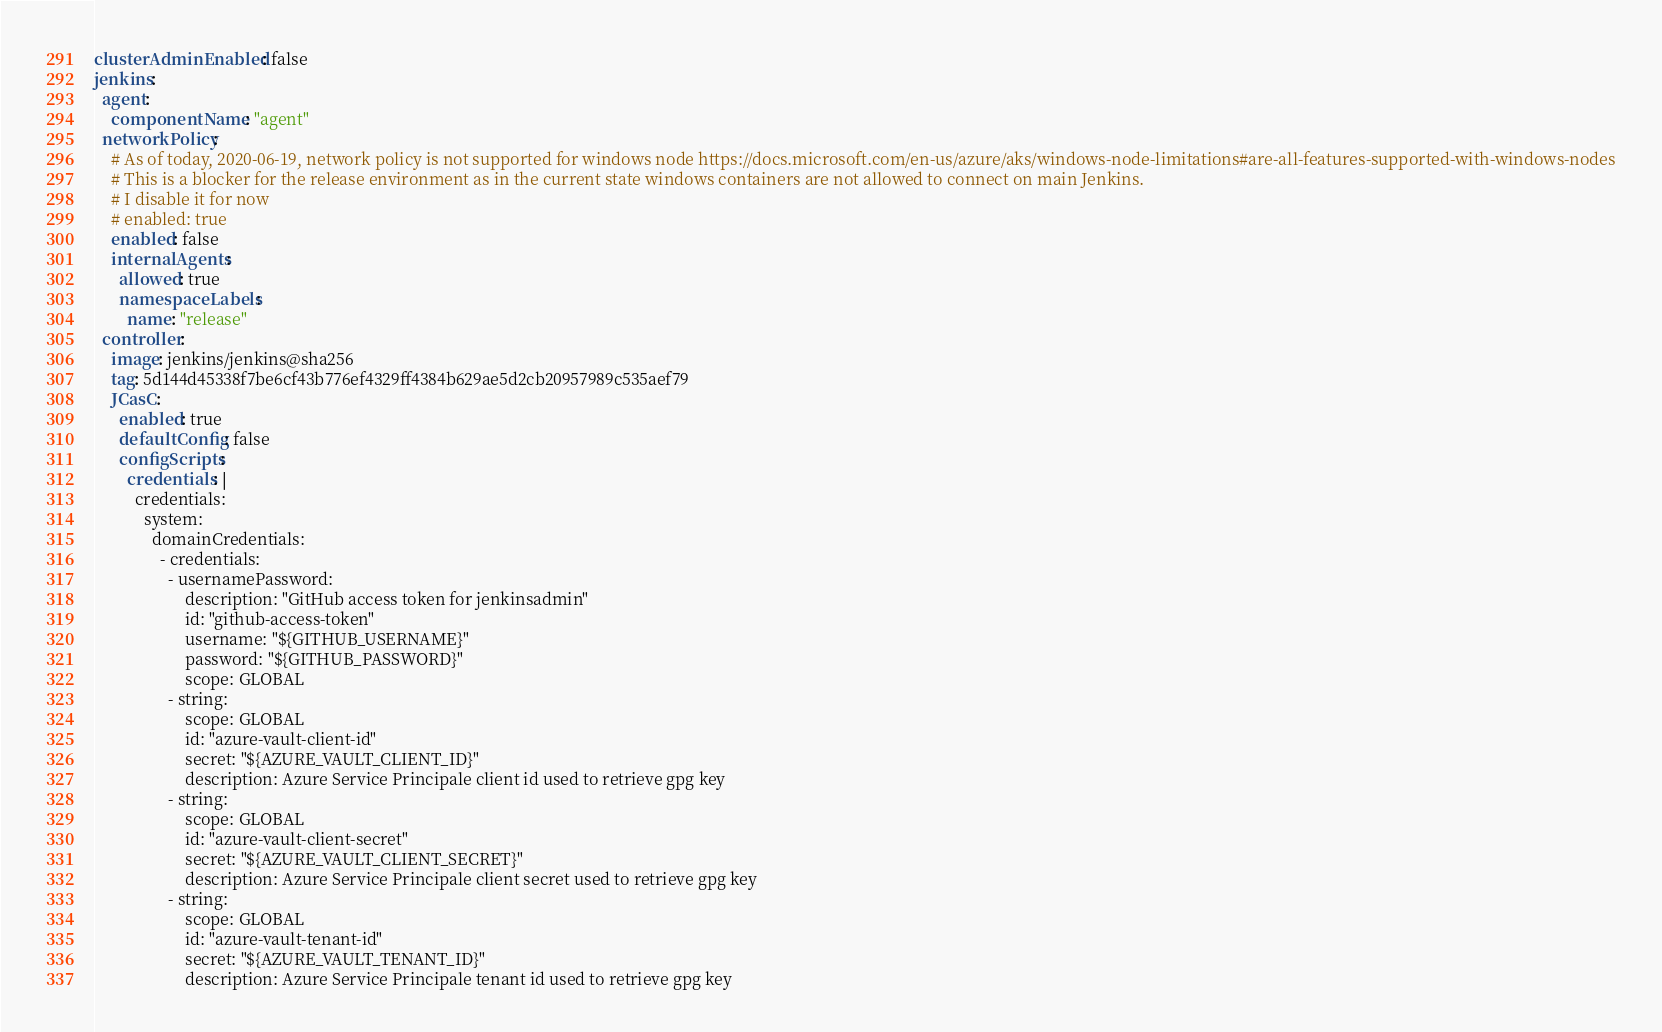<code> <loc_0><loc_0><loc_500><loc_500><_YAML_>clusterAdminEnabled: false
jenkins:
  agent:
    componentName: "agent"
  networkPolicy:
    # As of today, 2020-06-19, network policy is not supported for windows node https://docs.microsoft.com/en-us/azure/aks/windows-node-limitations#are-all-features-supported-with-windows-nodes
    # This is a blocker for the release environment as in the current state windows containers are not allowed to connect on main Jenkins.
    # I disable it for now
    # enabled: true
    enabled: false
    internalAgents:
      allowed: true
      namespaceLabels:
        name: "release"
  controller:
    image: jenkins/jenkins@sha256
    tag: 5d144d45338f7be6cf43b776ef4329ff4384b629ae5d2cb20957989c535aef79
    JCasC:
      enabled: true
      defaultConfig: false
      configScripts:
        credentials: |
          credentials:
            system:
              domainCredentials:
                - credentials:
                  - usernamePassword:
                      description: "GitHub access token for jenkinsadmin"
                      id: "github-access-token"
                      username: "${GITHUB_USERNAME}"
                      password: "${GITHUB_PASSWORD}"
                      scope: GLOBAL
                  - string:
                      scope: GLOBAL
                      id: "azure-vault-client-id"
                      secret: "${AZURE_VAULT_CLIENT_ID}"
                      description: Azure Service Principale client id used to retrieve gpg key
                  - string:
                      scope: GLOBAL
                      id: "azure-vault-client-secret"
                      secret: "${AZURE_VAULT_CLIENT_SECRET}"
                      description: Azure Service Principale client secret used to retrieve gpg key
                  - string:
                      scope: GLOBAL
                      id: "azure-vault-tenant-id"
                      secret: "${AZURE_VAULT_TENANT_ID}"
                      description: Azure Service Principale tenant id used to retrieve gpg key</code> 